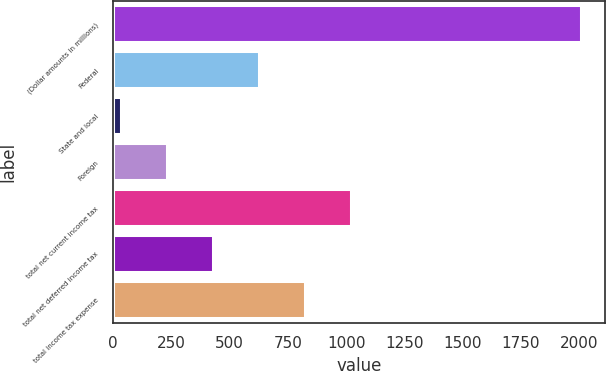Convert chart to OTSL. <chart><loc_0><loc_0><loc_500><loc_500><bar_chart><fcel>(Dollar amounts in millions)<fcel>Federal<fcel>State and local<fcel>Foreign<fcel>total net current income tax<fcel>total net deferred income tax<fcel>total income tax expense<nl><fcel>2009<fcel>627.9<fcel>36<fcel>233.3<fcel>1022.5<fcel>430.6<fcel>825.2<nl></chart> 